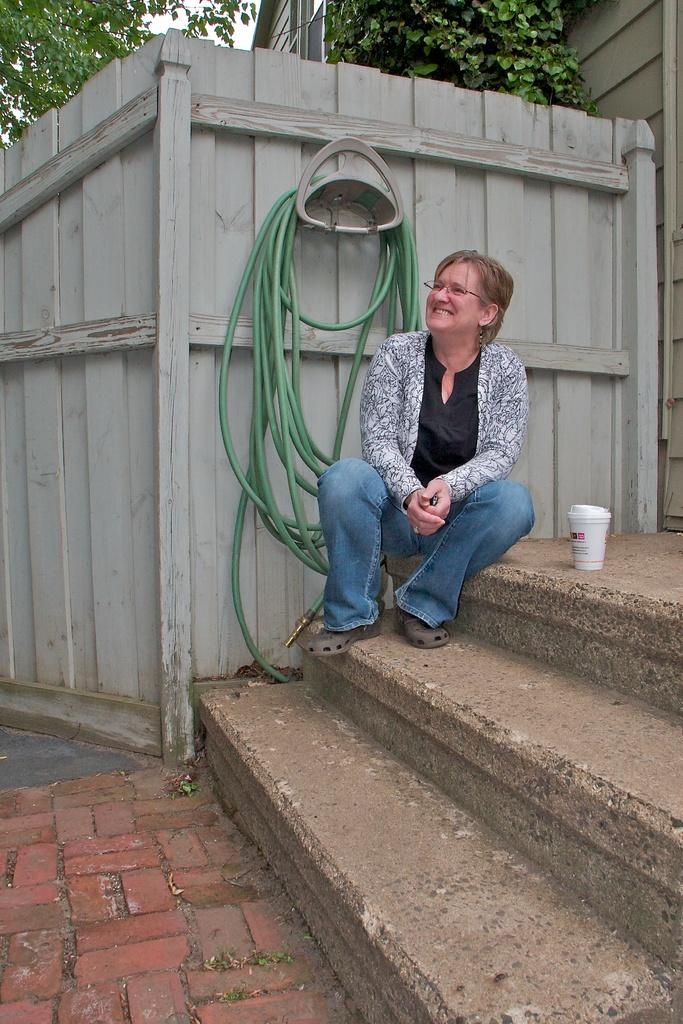What is the woman in the image doing? The woman is sitting on the steps. What is located beside the woman? There is an object beside the woman. What can be seen hanging on the wall in the image? There is a pipe hanging on the wall. What type of structure is visible in the image? There is a building visible in the image. What type of vegetation is present in the image? There are trees present in the image. How many pigs are visible in the image? There are no pigs present in the image. What color is the woman's shirt in the image? The provided facts do not mention the woman's shirt, so we cannot answer this question. 